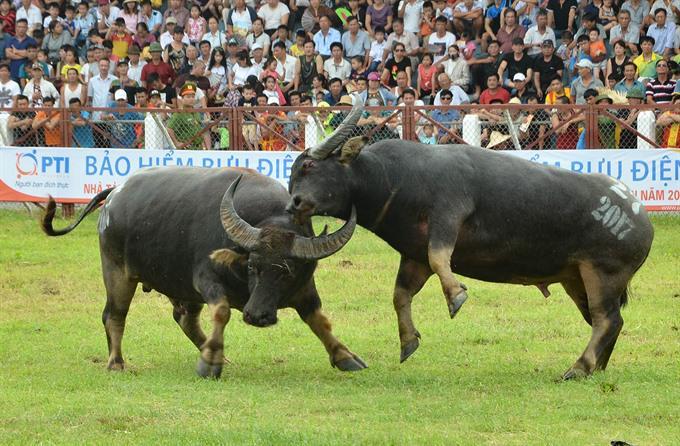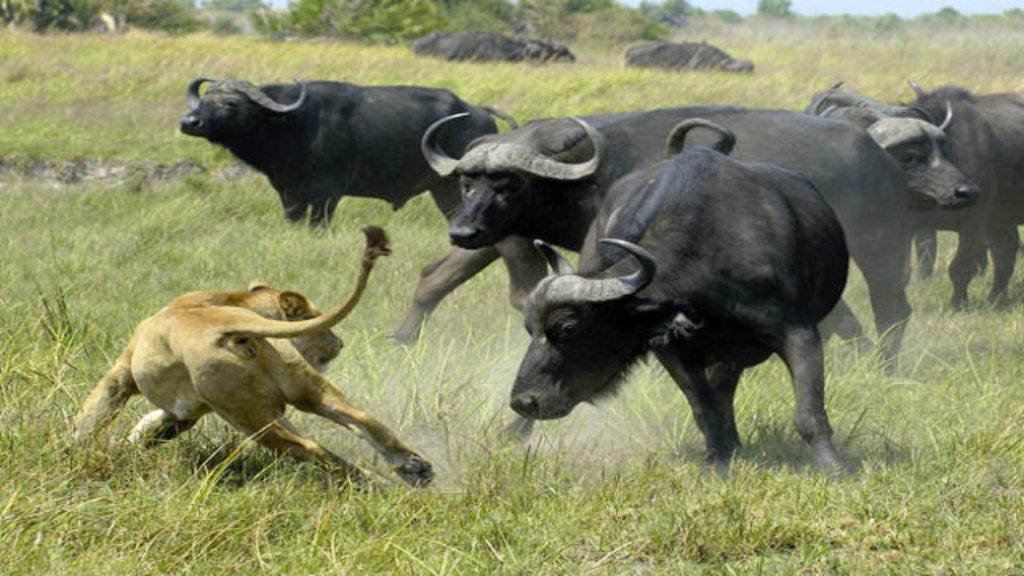The first image is the image on the left, the second image is the image on the right. Considering the images on both sides, is "In the left image, both water buffalo have all four feet on the ground and their horns are locked." valid? Answer yes or no. No. The first image is the image on the left, the second image is the image on the right. Given the left and right images, does the statement "At least one bison's head is touching the ground." hold true? Answer yes or no. No. 